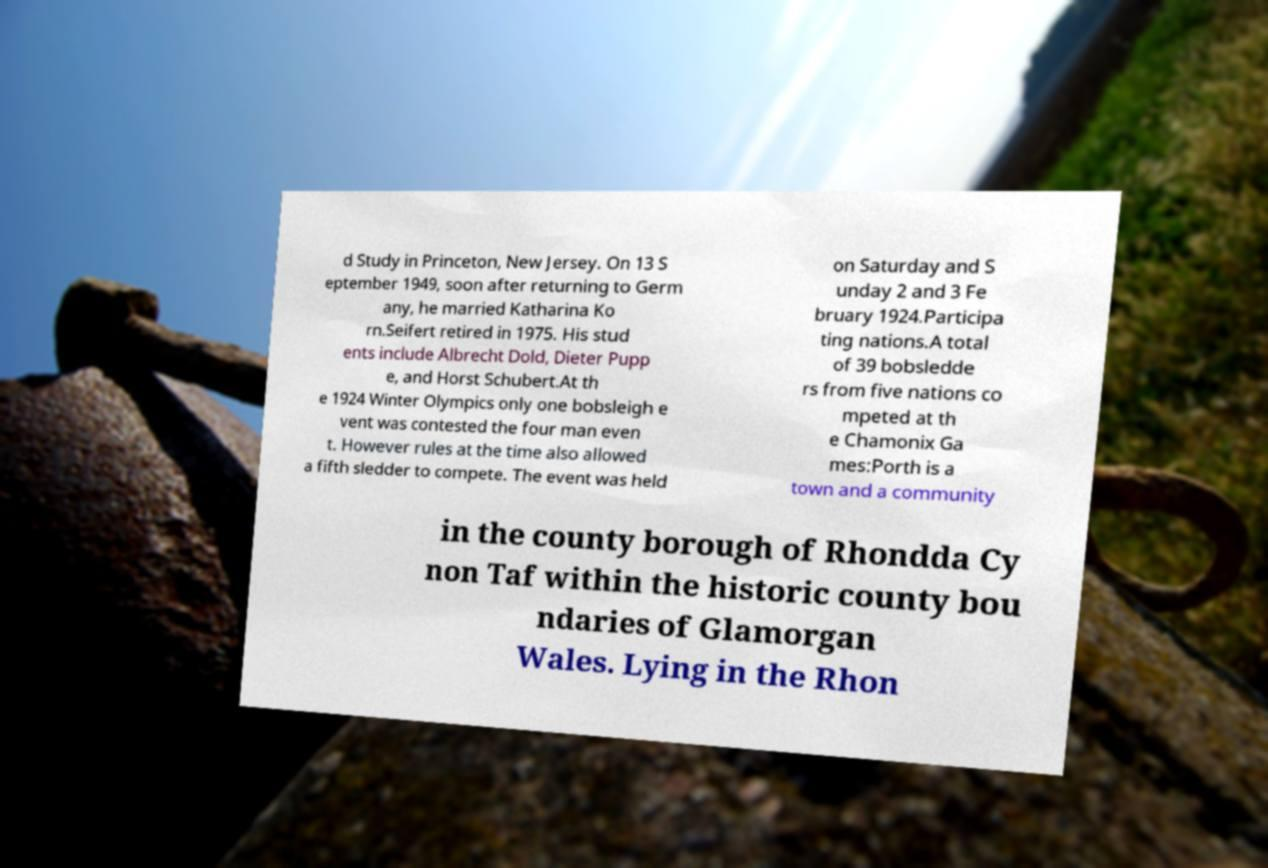I need the written content from this picture converted into text. Can you do that? d Study in Princeton, New Jersey. On 13 S eptember 1949, soon after returning to Germ any, he married Katharina Ko rn.Seifert retired in 1975. His stud ents include Albrecht Dold, Dieter Pupp e, and Horst Schubert.At th e 1924 Winter Olympics only one bobsleigh e vent was contested the four man even t. However rules at the time also allowed a fifth sledder to compete. The event was held on Saturday and S unday 2 and 3 Fe bruary 1924.Participa ting nations.A total of 39 bobsledde rs from five nations co mpeted at th e Chamonix Ga mes:Porth is a town and a community in the county borough of Rhondda Cy non Taf within the historic county bou ndaries of Glamorgan Wales. Lying in the Rhon 